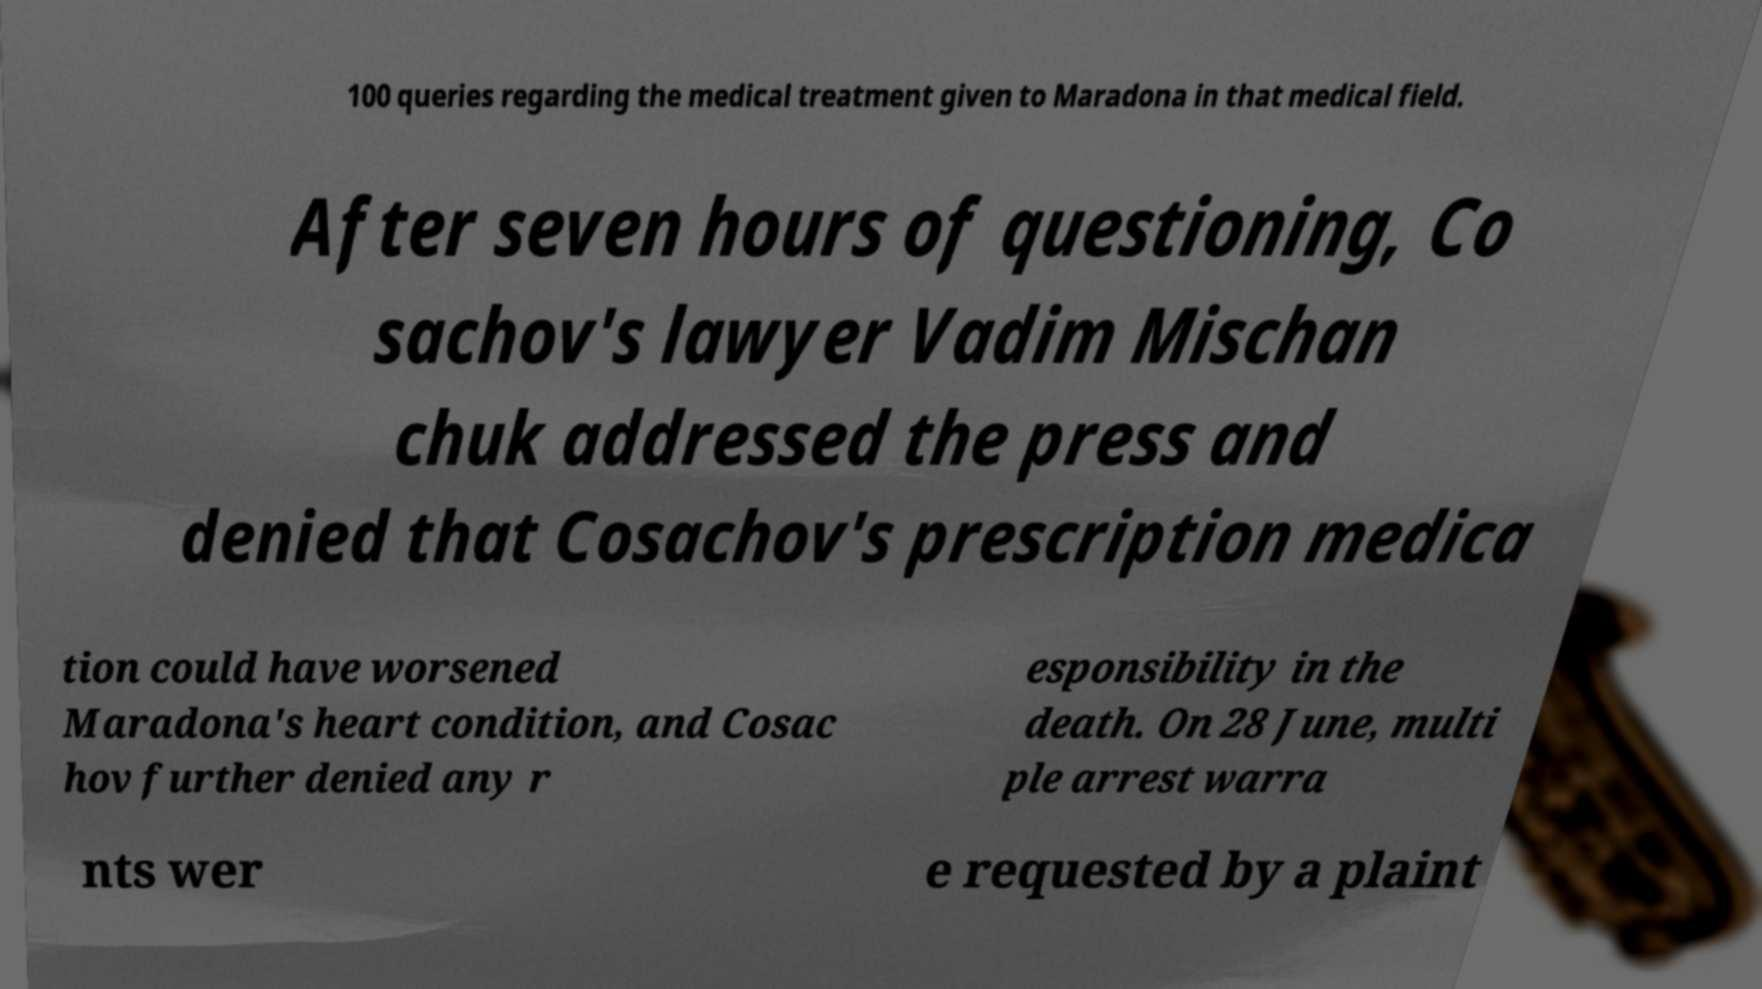Can you read and provide the text displayed in the image?This photo seems to have some interesting text. Can you extract and type it out for me? 100 queries regarding the medical treatment given to Maradona in that medical field. After seven hours of questioning, Co sachov's lawyer Vadim Mischan chuk addressed the press and denied that Cosachov's prescription medica tion could have worsened Maradona's heart condition, and Cosac hov further denied any r esponsibility in the death. On 28 June, multi ple arrest warra nts wer e requested by a plaint 